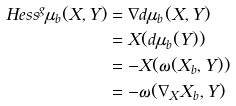Convert formula to latex. <formula><loc_0><loc_0><loc_500><loc_500>H e s s ^ { g } \mu _ { b } ( X , Y ) & = \nabla d \mu _ { b } ( X , Y ) \\ & = X ( d \mu _ { b } ( Y ) ) \\ & = - X ( \omega ( X _ { b } , Y ) ) \\ & = - \omega ( \nabla _ { X } X _ { b } , Y )</formula> 